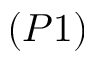Convert formula to latex. <formula><loc_0><loc_0><loc_500><loc_500>( P 1 )</formula> 